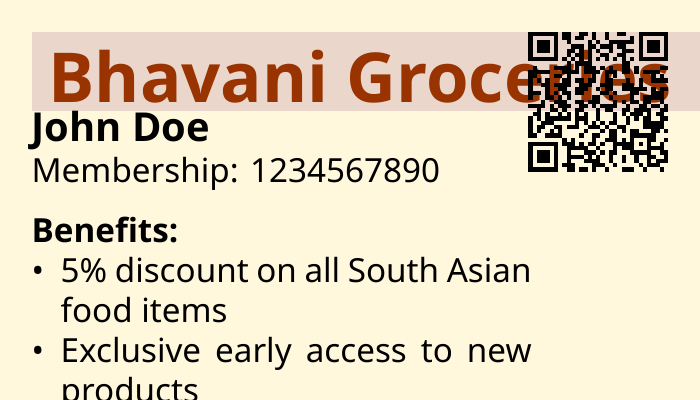What is the name of the grocery store? The grocery store's name is displayed prominently on the card.
Answer: Bhavani Groceries Who is the member named on the card? The card identifies the individual as a member by name.
Answer: John Doe What is the membership number? The membership number is provided on the card for identification purposes.
Answer: 1234567890 What discount is available on South Asian food items? The card outlines the specific discounts available for members.
Answer: 5% discount What is the birthday benefit provided to members? The card specifies what benefit members receive during their birthday month.
Answer: 10% off on your birthday month What type of offers do members receive each month? The card mentions special offers that are exclusive to members.
Answer: Monthly special offers on selected items What feature allows quick access to account details? The card includes a specific feature for easy access to information.
Answer: QR code What can members expect regarding new products? The card indicates a benefit that relates to product launches.
Answer: Exclusive early access to new products 